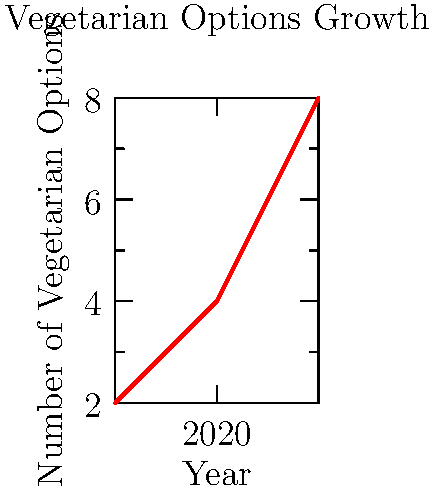Based on the line chart showing the growth of vegetarian options in a fast food chain from 2018 to 2022, what is the average annual increase in the number of vegetarian menu items? To calculate the average annual increase in vegetarian options:

1. Calculate total increase: 
   $8 - 2 = 6$ options (from 2018 to 2022)

2. Determine the number of years:
   $2022 - 2018 = 4$ years

3. Calculate average annual increase:
   $\frac{\text{Total increase}}{\text{Number of years}} = \frac{6}{4} = 1.5$

The average annual increase is 1.5 vegetarian options per year.
Answer: 1.5 options per year 